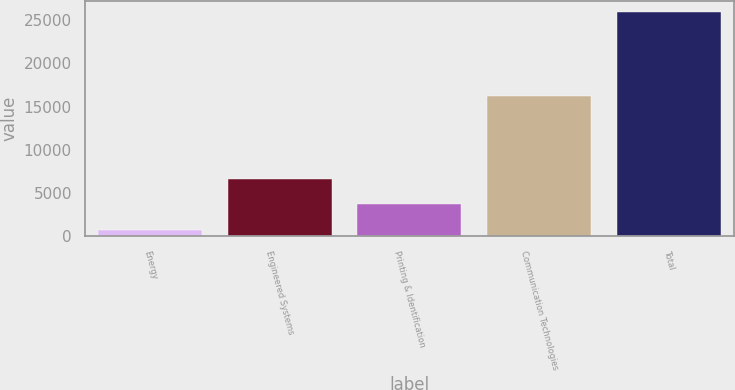<chart> <loc_0><loc_0><loc_500><loc_500><bar_chart><fcel>Energy<fcel>Engineered Systems<fcel>Printing & Identification<fcel>Communication Technologies<fcel>Total<nl><fcel>712<fcel>6598<fcel>3772<fcel>16251<fcel>25909<nl></chart> 